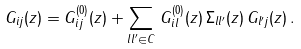<formula> <loc_0><loc_0><loc_500><loc_500>G _ { i j } ( z ) = G ^ { ( 0 ) } _ { i j } ( z ) + \sum _ { l l ^ { \prime } \in C } \, G ^ { ( 0 ) } _ { i l } ( z ) \, \Sigma _ { l l ^ { \prime } } ( z ) \, G _ { l ^ { \prime } j } ( z ) \, .</formula> 